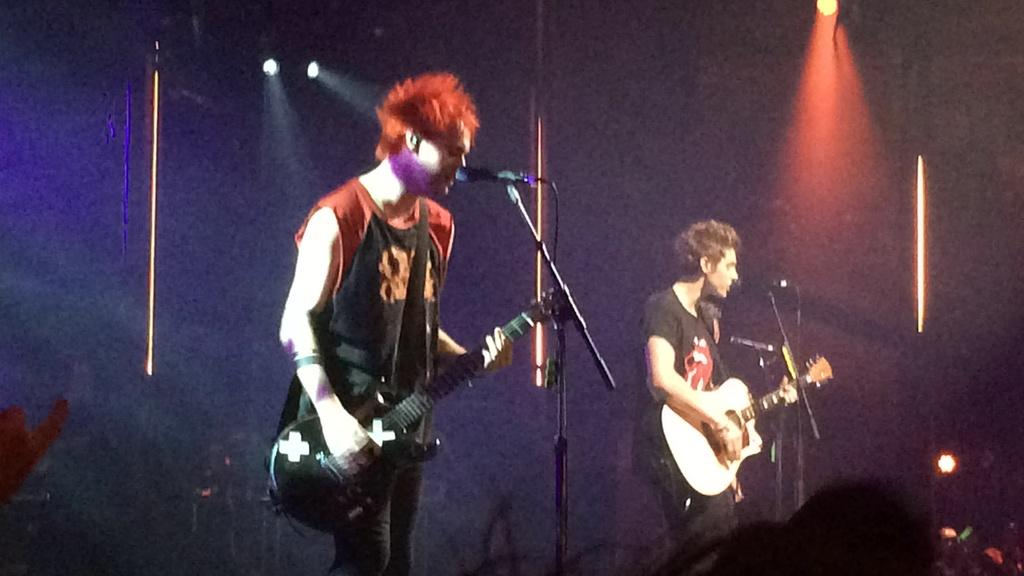How many people are playing the guitar in the image? There are two men in the image, and they are both playing the guitar. What are the men doing while playing the guitar? The men are singing through a microphone. Where is the microphone positioned in relation to the men? The microphone is in front of the men. What can be seen in front of the men? There is a crowd in front of the men. What is visible at the top of the image? There are lights visible at the top of the image. What type of pancake is being served to the beginner guitar player in the image? There is no pancake or beginner guitar player present in the image. How does the mine affect the performance of the men in the image? There is no mine mentioned or visible in the image, so it cannot affect the performance of the men. 